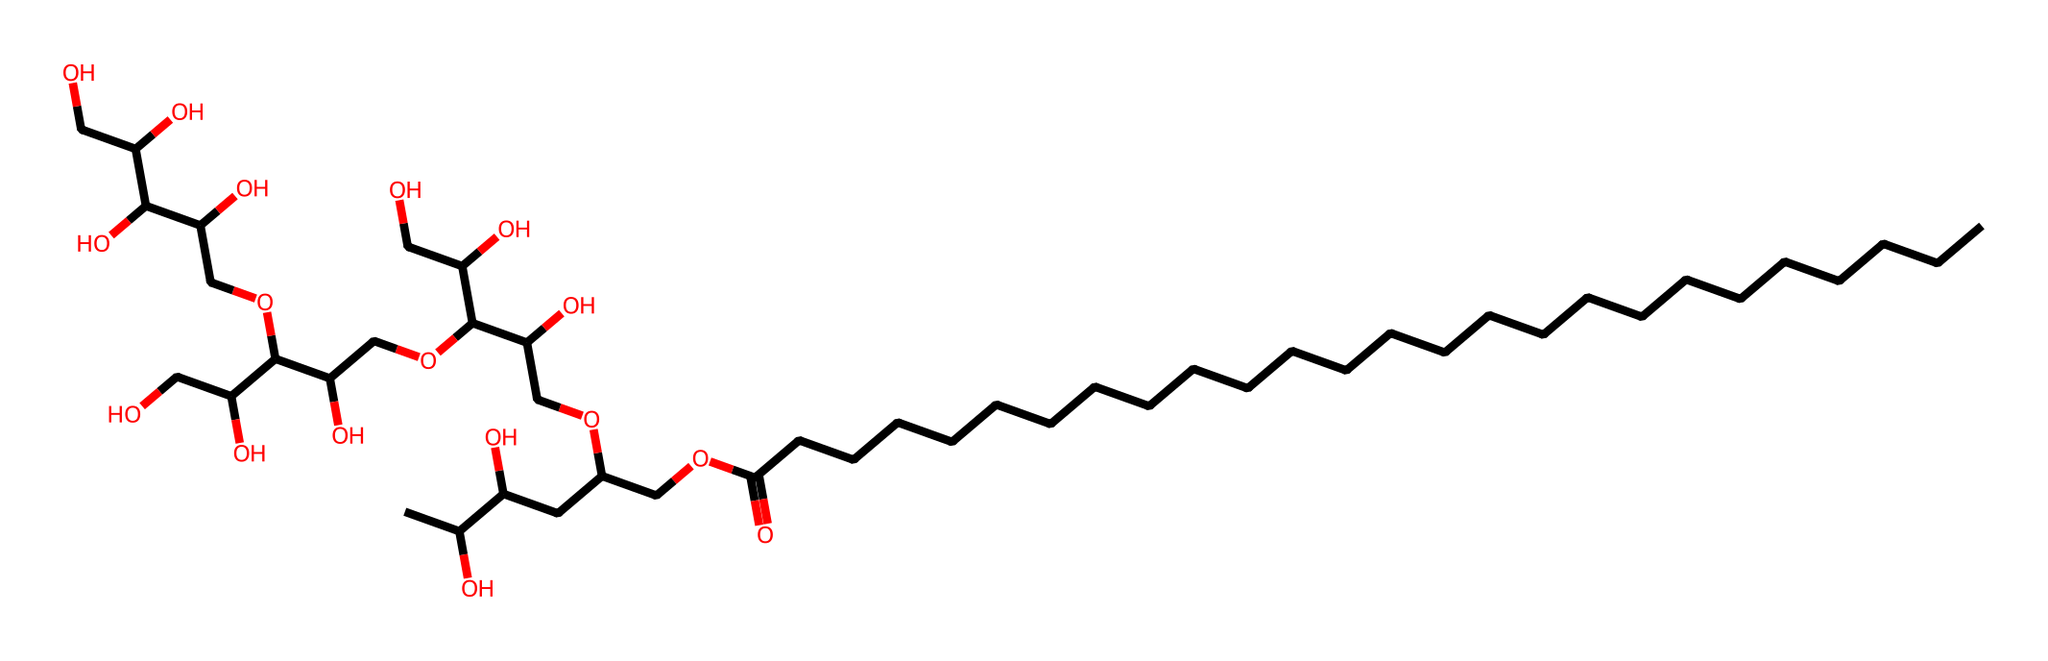What is the long-chain fatty acid component of polysorbate 20? The structure denotes a long carbon chain, specifically containing 20 carbon atoms in the fatty acid segment. Therefore, it indicates that the fatty acid part consists of 20 carbons.
Answer: 20 How many hydroxyl groups are present in the molecule? By analyzing the molecular structure, we can count the individual hydroxyl (OH) groups attached to the carbon skeleton. This molecule has 10 hydroxyl groups present.
Answer: 10 What type of surfactant does polysorbate 20 represent? Since polysorbate 20 is characterized by both hydrophilic (water-attracting) and hydrophobic (water-repelling) parts in its structure, it is classified as a nonionic surfactant.
Answer: nonionic What is the total number of carbon atoms in polysorbate 20? Counting the number of carbon atoms in both the fatty acid chain and other components within the structure reveals a total of 30 carbon atoms in the complete molecule.
Answer: 30 How many ester linkages are present in polysorbate 20? Analyzing the structure, the connecting points marked by ester bonds can be determined. There are 5 ester linkages identified in the molecule.
Answer: 5 Which segment contributes to solubility in water? The numerous hydroxyl groups and the polar character of the ethylene glycol units within the structure enhance its solubility in water. This hydrophilic portion is responsible for solubility.
Answer: hydroxyl groups 